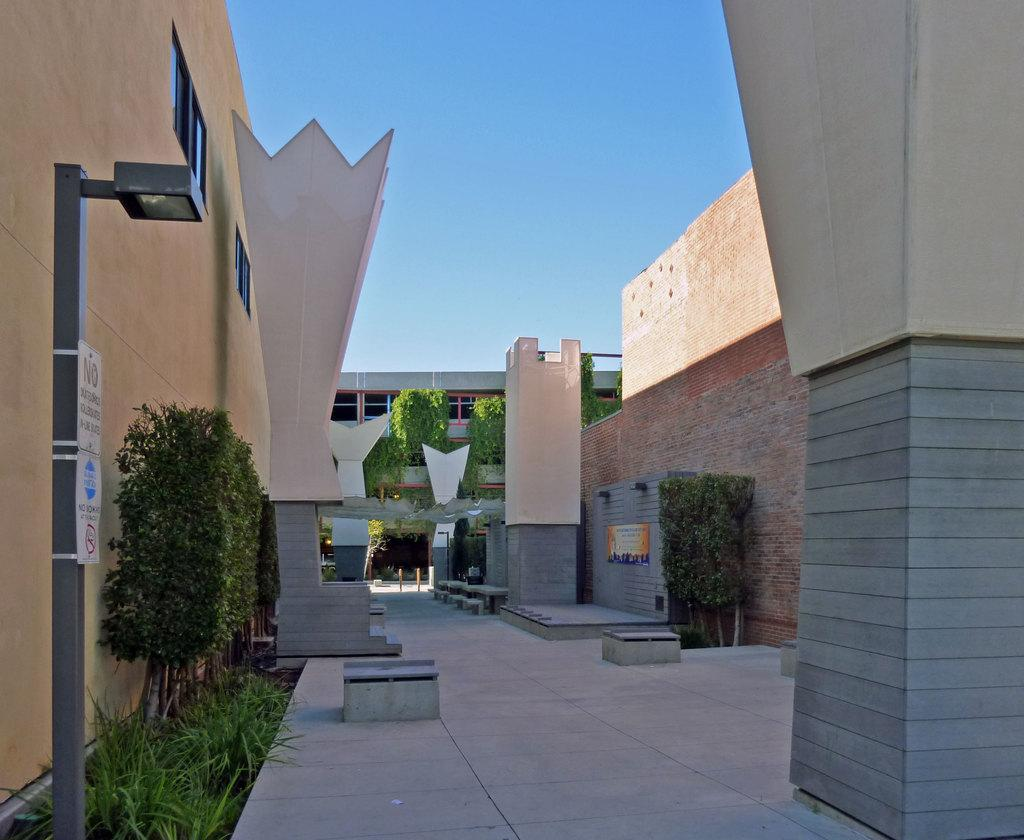<image>
Write a terse but informative summary of the picture. An empty path between 2 buildings with a no smoking sign on the left side. 